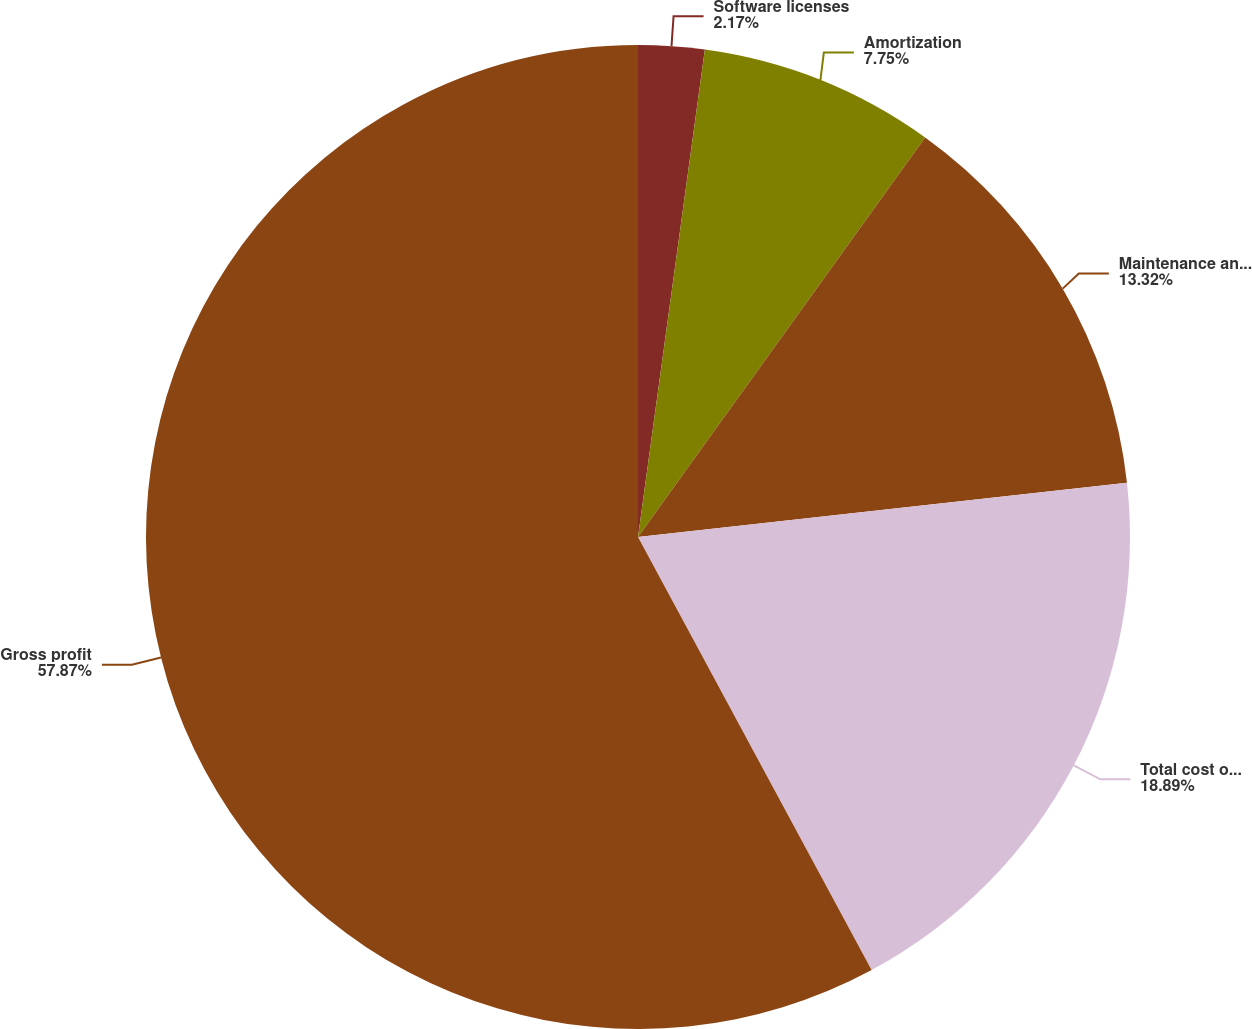Convert chart to OTSL. <chart><loc_0><loc_0><loc_500><loc_500><pie_chart><fcel>Software licenses<fcel>Amortization<fcel>Maintenance and service<fcel>Total cost of sales<fcel>Gross profit<nl><fcel>2.17%<fcel>7.75%<fcel>13.32%<fcel>18.89%<fcel>57.88%<nl></chart> 